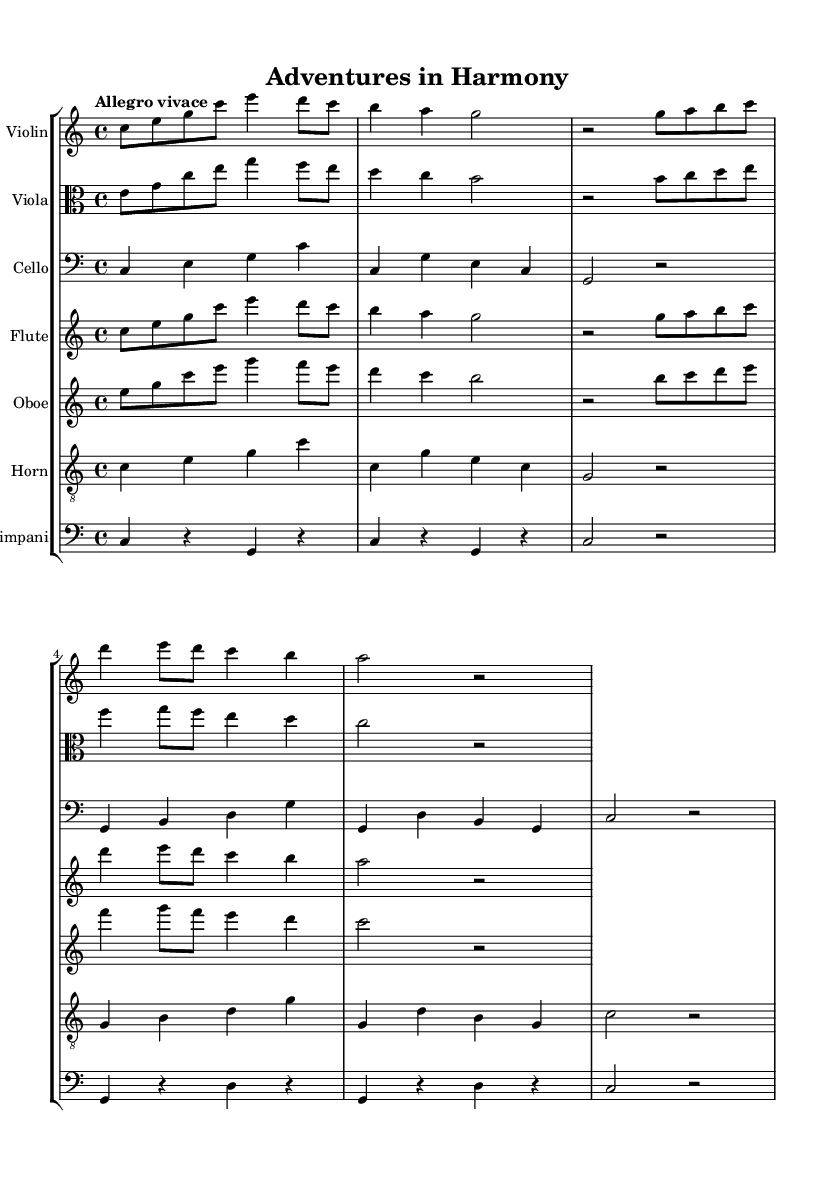What is the key signature of this music? The key signature is indicated at the beginning of the sheet music, where there are no sharps or flats noted, which corresponds to C major.
Answer: C major What is the time signature of this music? The time signature is found at the beginning of the score, indicated by the "4/4" marking, which shows there are four beats per measure.
Answer: 4/4 What is the tempo marking for this piece? The tempo marking is written above the staff and reads "Allegro vivace," indicating a fast and lively pace for the music.
Answer: Allegro vivace How many instruments are featured in this score? The score displays seven staves, each representing a different instrument, which indicates that seven instruments are featured.
Answer: Seven Which instrument plays the highest pitch in the score? By examining the notes written for each instrument, the flute is written in a higher range than the others, as it is located in the higher staff compared to the rest.
Answer: Flute Which measure contains the first rest in the cello part? Looking through the cello part, the first measure with a rest occurs in measure 3, where a half note rest appears after the first two measures of notes.
Answer: Measure 3 What is the rhythmic value of the first note in the viola part? The first note in the viola part is an eighth note, which is clear from its placement and the notehead's shape in the score.
Answer: Eighth note 